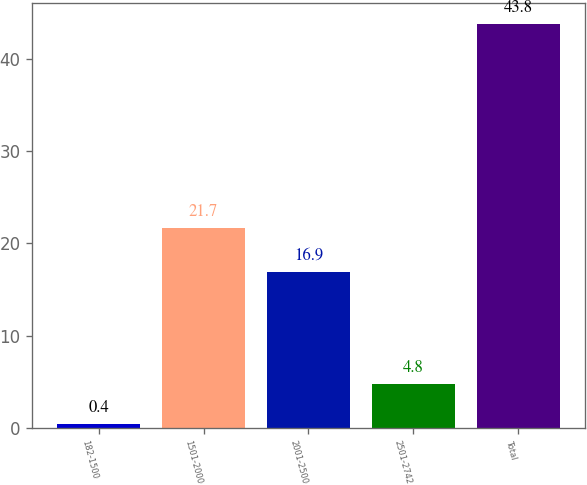<chart> <loc_0><loc_0><loc_500><loc_500><bar_chart><fcel>182-1500<fcel>1501-2000<fcel>2001-2500<fcel>2501-2742<fcel>Total<nl><fcel>0.4<fcel>21.7<fcel>16.9<fcel>4.8<fcel>43.8<nl></chart> 